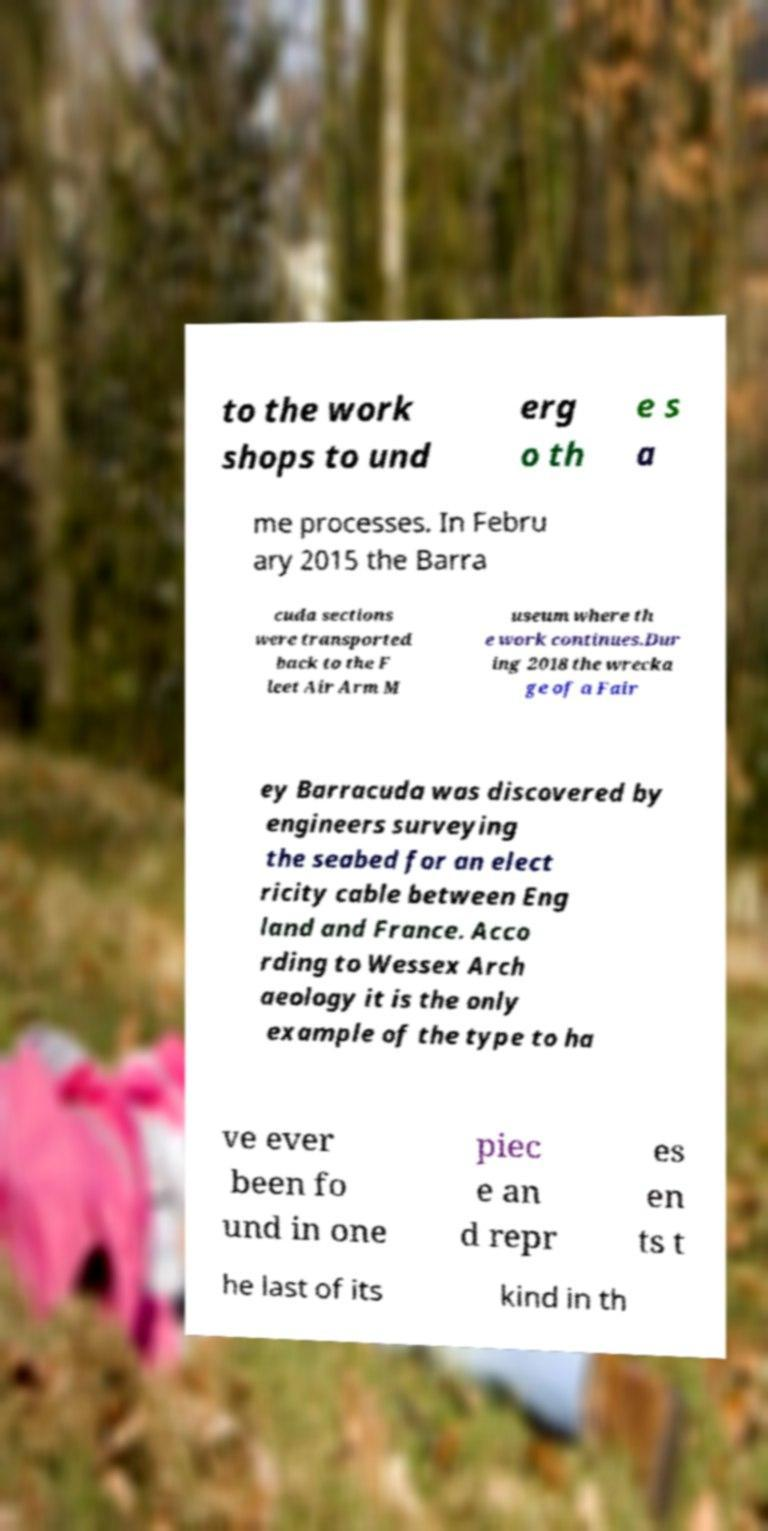What messages or text are displayed in this image? I need them in a readable, typed format. to the work shops to und erg o th e s a me processes. In Febru ary 2015 the Barra cuda sections were transported back to the F leet Air Arm M useum where th e work continues.Dur ing 2018 the wrecka ge of a Fair ey Barracuda was discovered by engineers surveying the seabed for an elect ricity cable between Eng land and France. Acco rding to Wessex Arch aeology it is the only example of the type to ha ve ever been fo und in one piec e an d repr es en ts t he last of its kind in th 